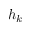<formula> <loc_0><loc_0><loc_500><loc_500>h _ { k }</formula> 